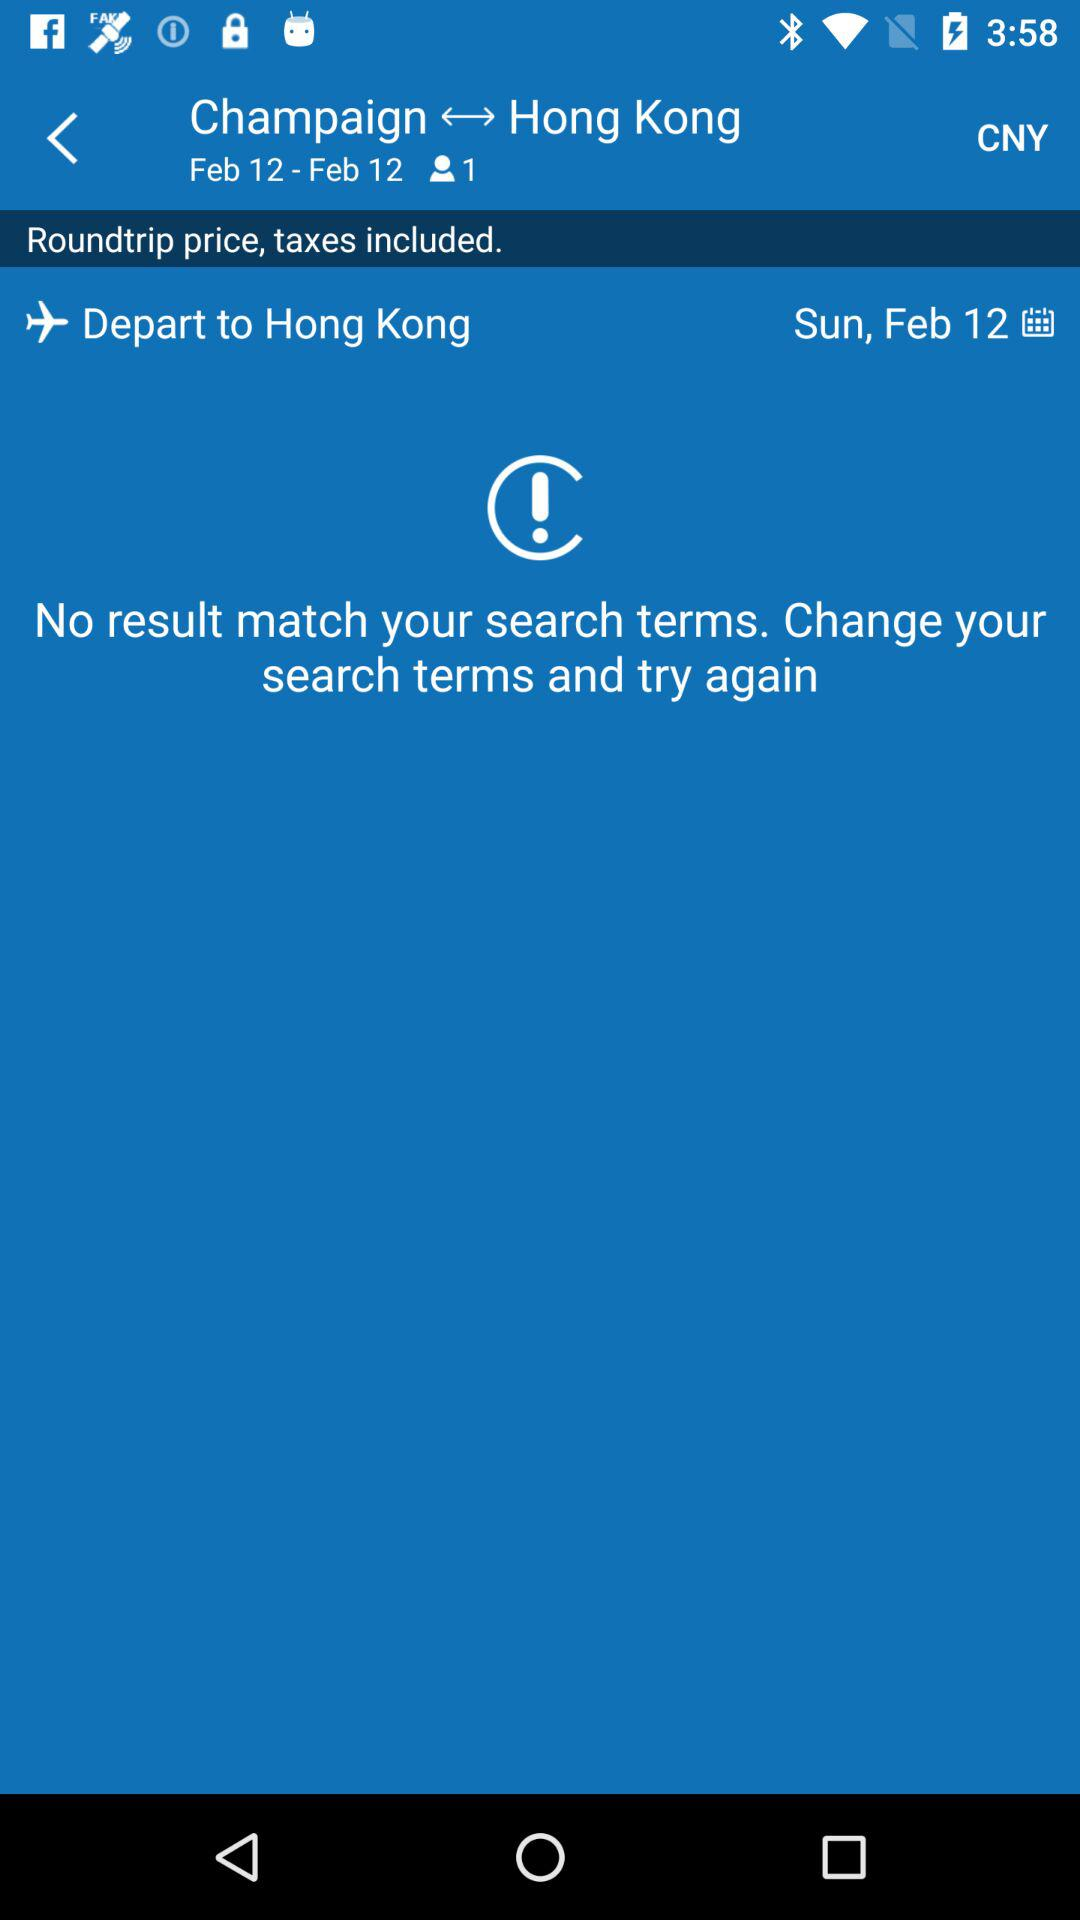Is there a matching result? There is no matching result. 